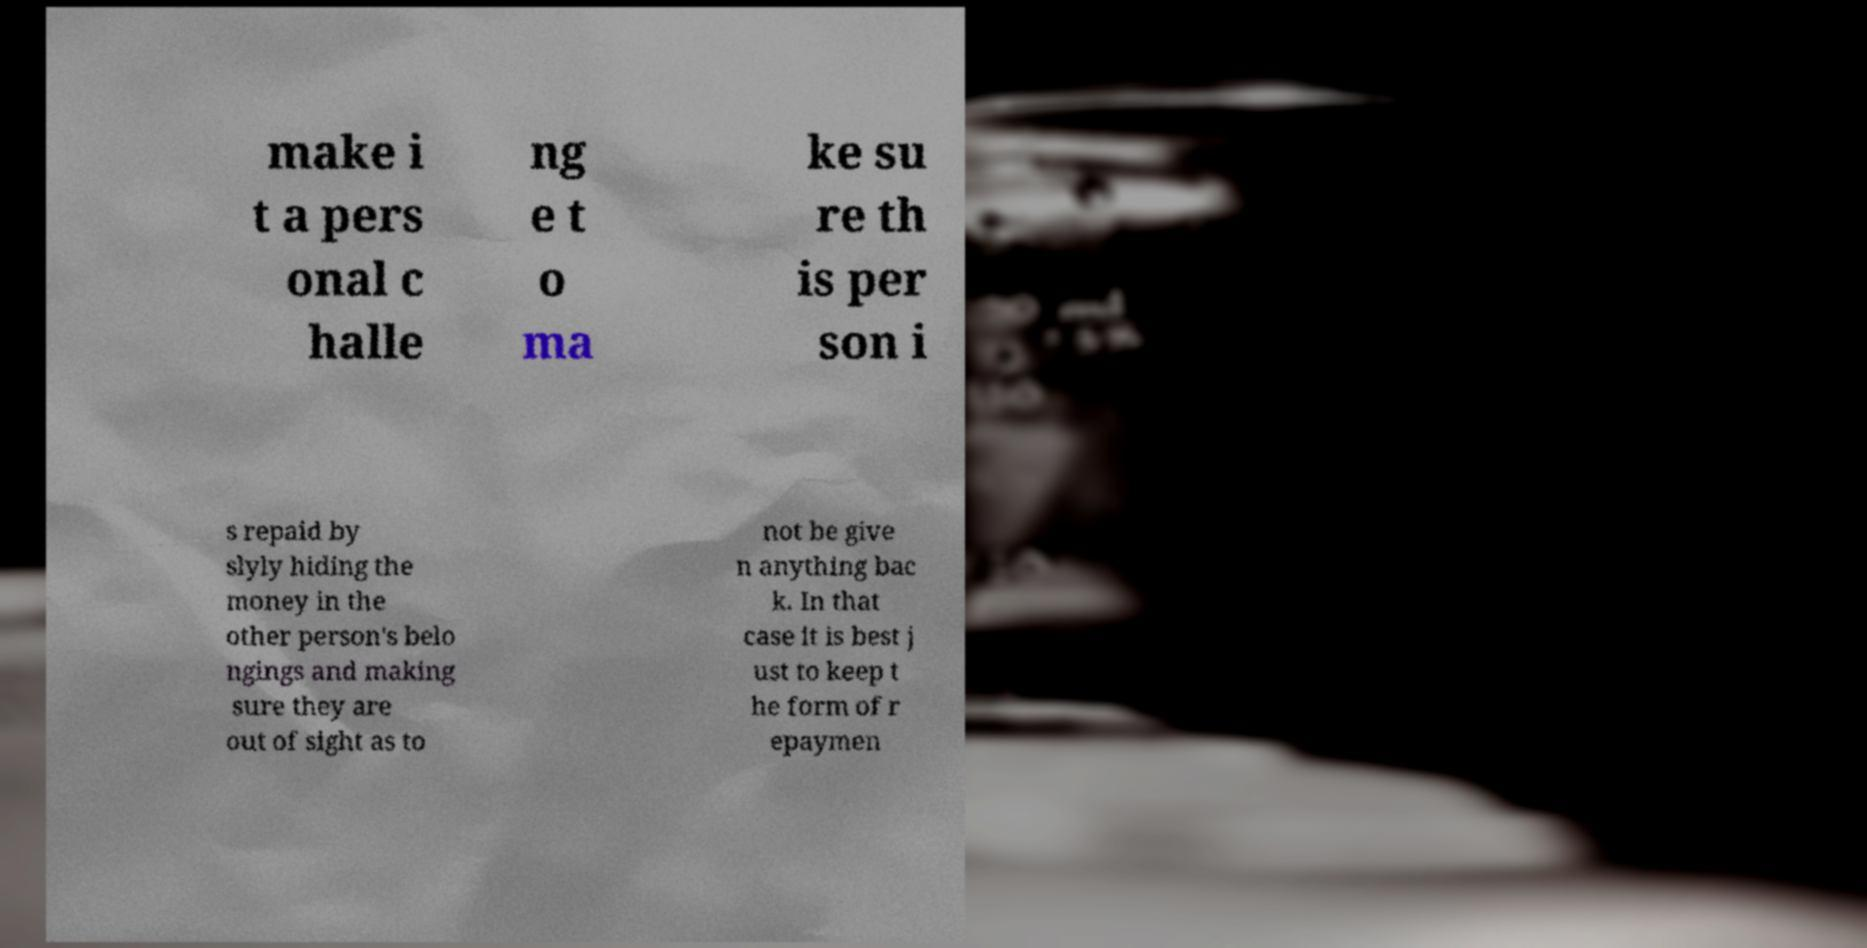Can you read and provide the text displayed in the image?This photo seems to have some interesting text. Can you extract and type it out for me? make i t a pers onal c halle ng e t o ma ke su re th is per son i s repaid by slyly hiding the money in the other person's belo ngings and making sure they are out of sight as to not be give n anything bac k. In that case it is best j ust to keep t he form of r epaymen 